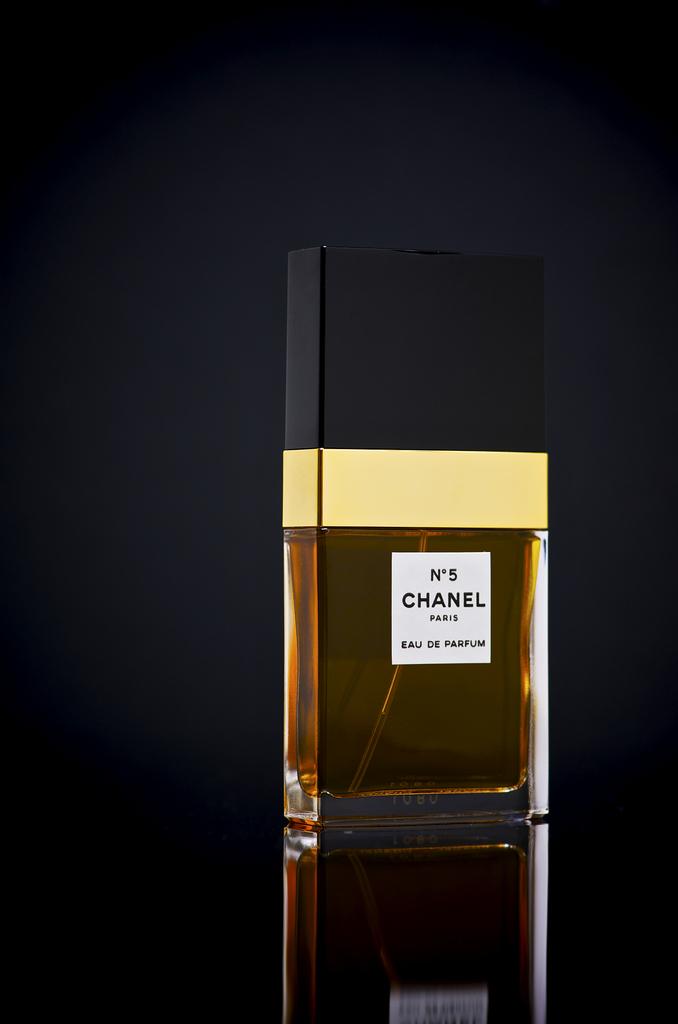What number is the perfume?
Offer a terse response. 5. 